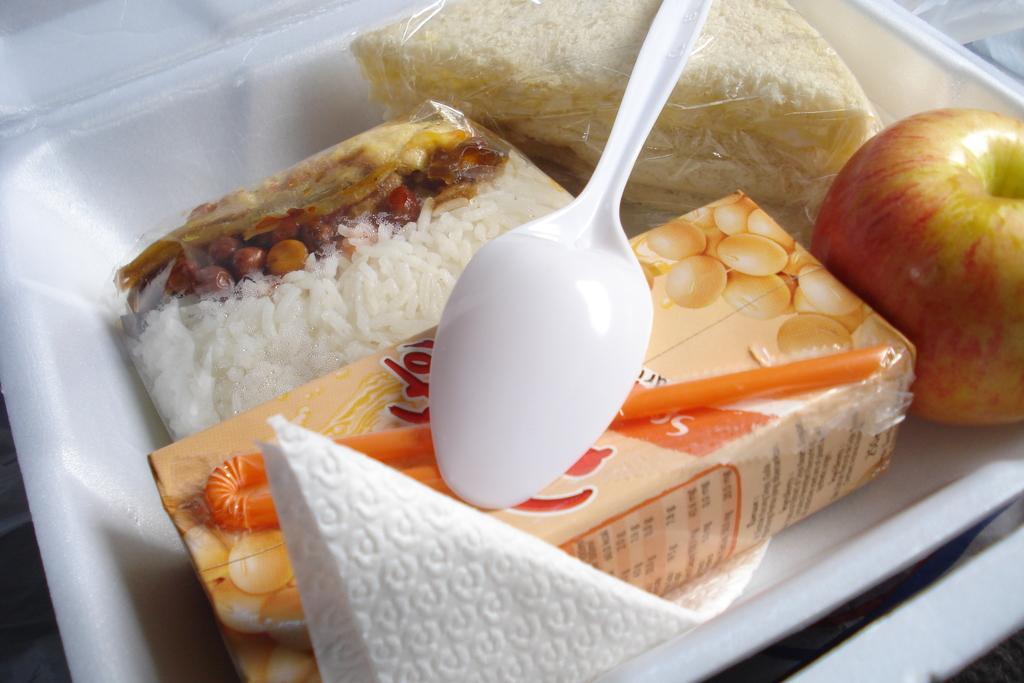Describe this image in one or two sentences. In this image there are food items, apple, juice, plastic spoon and tissue are arranged in a thermocol box. 